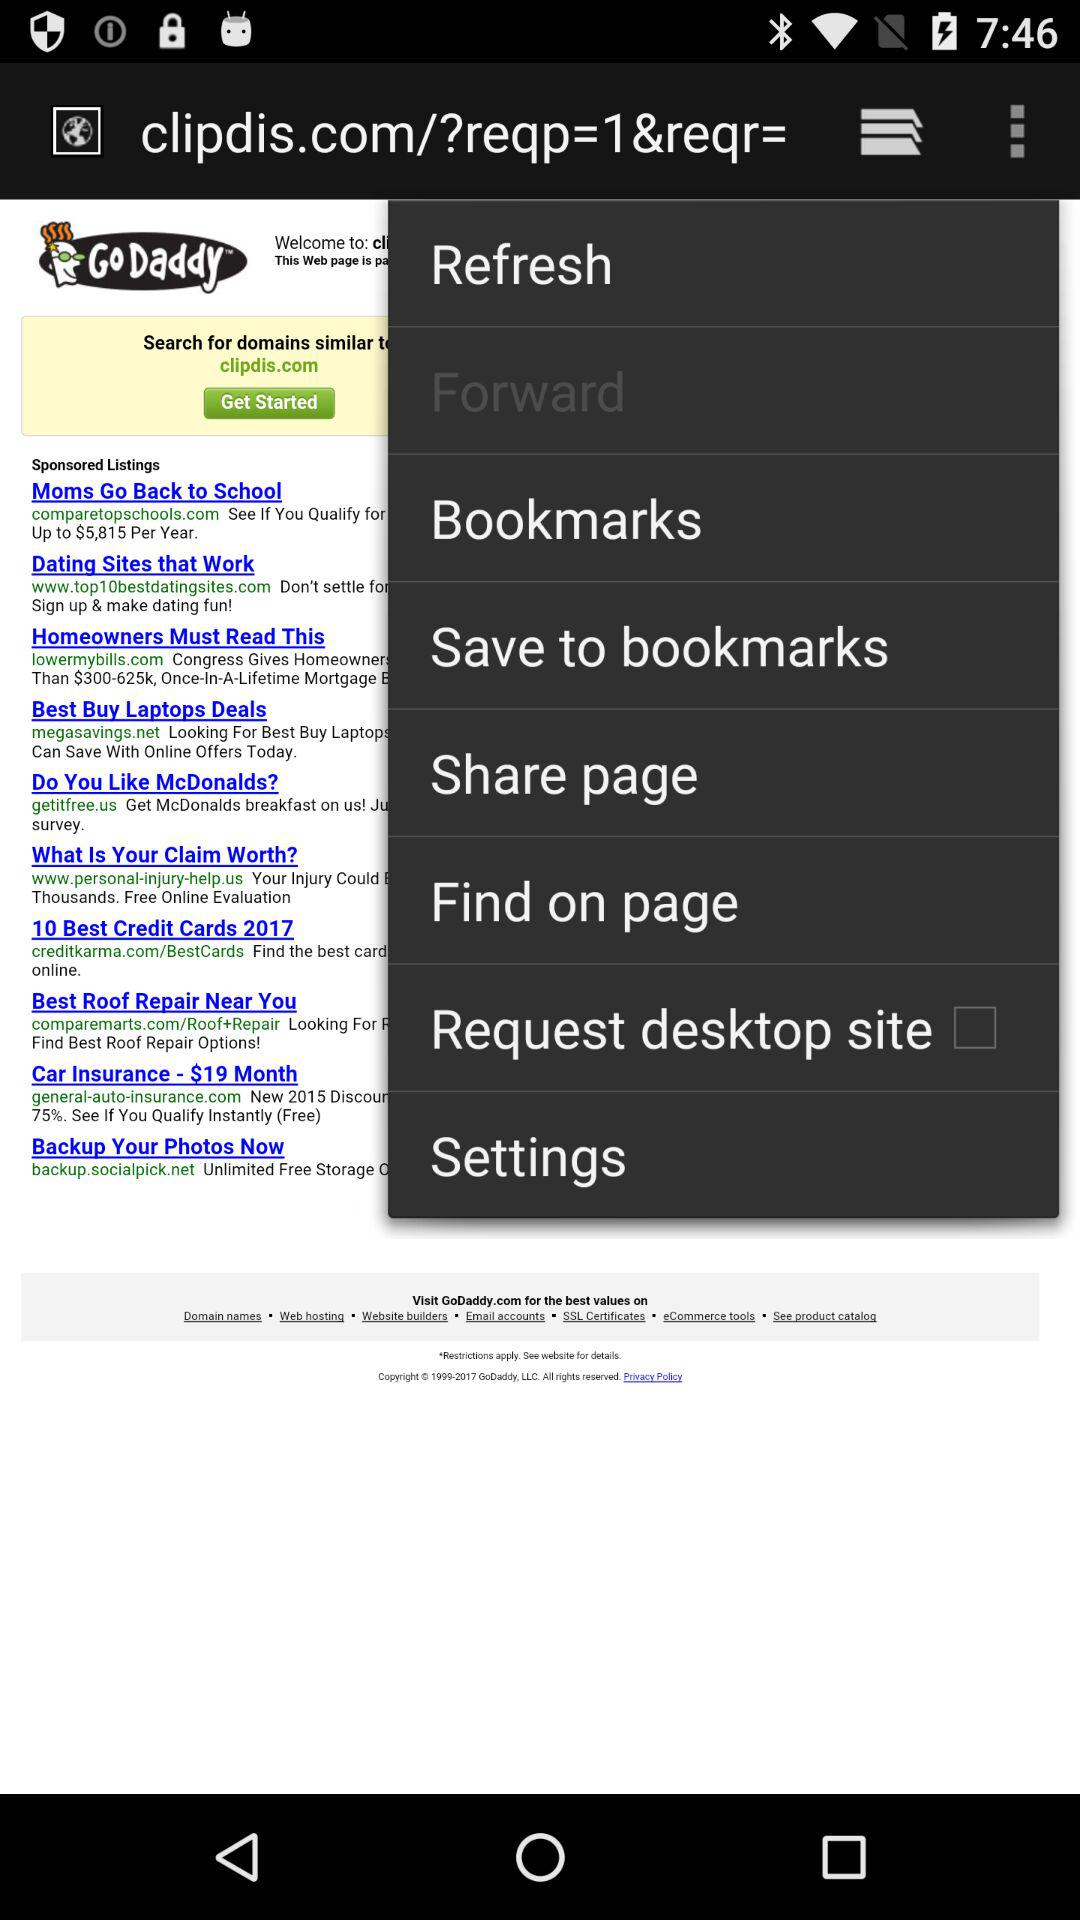What is the status of the "Request desktop site" setting? The status is "off". 